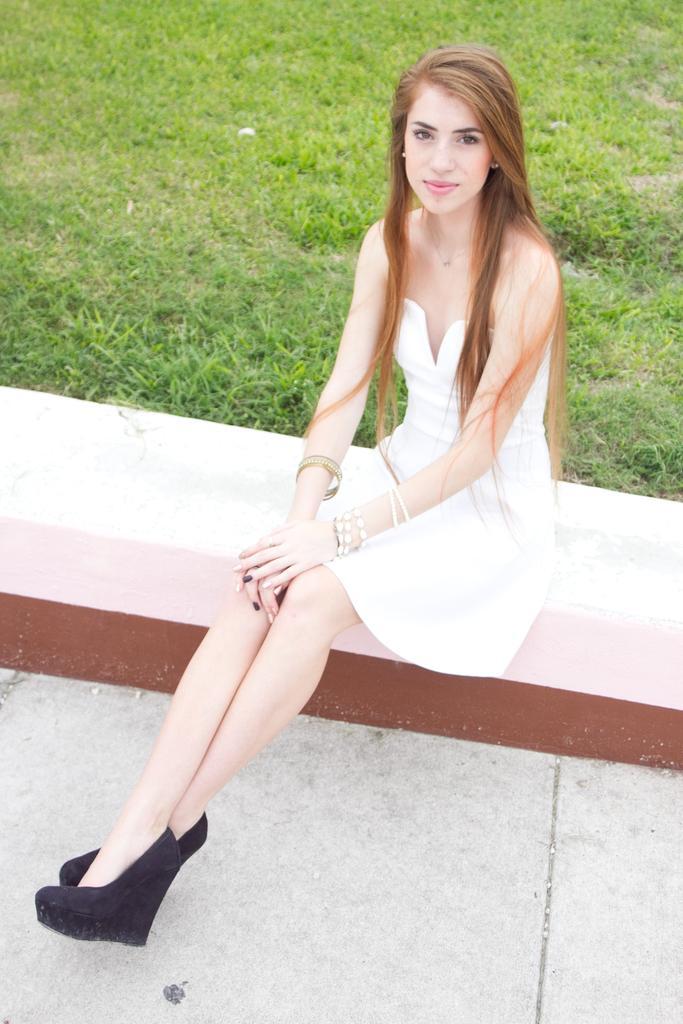How would you summarize this image in a sentence or two? In the foreground of the picture we can see a beautiful woman in white dress sitting on a bench. At the bottom it is floor. In the background there is grass. 